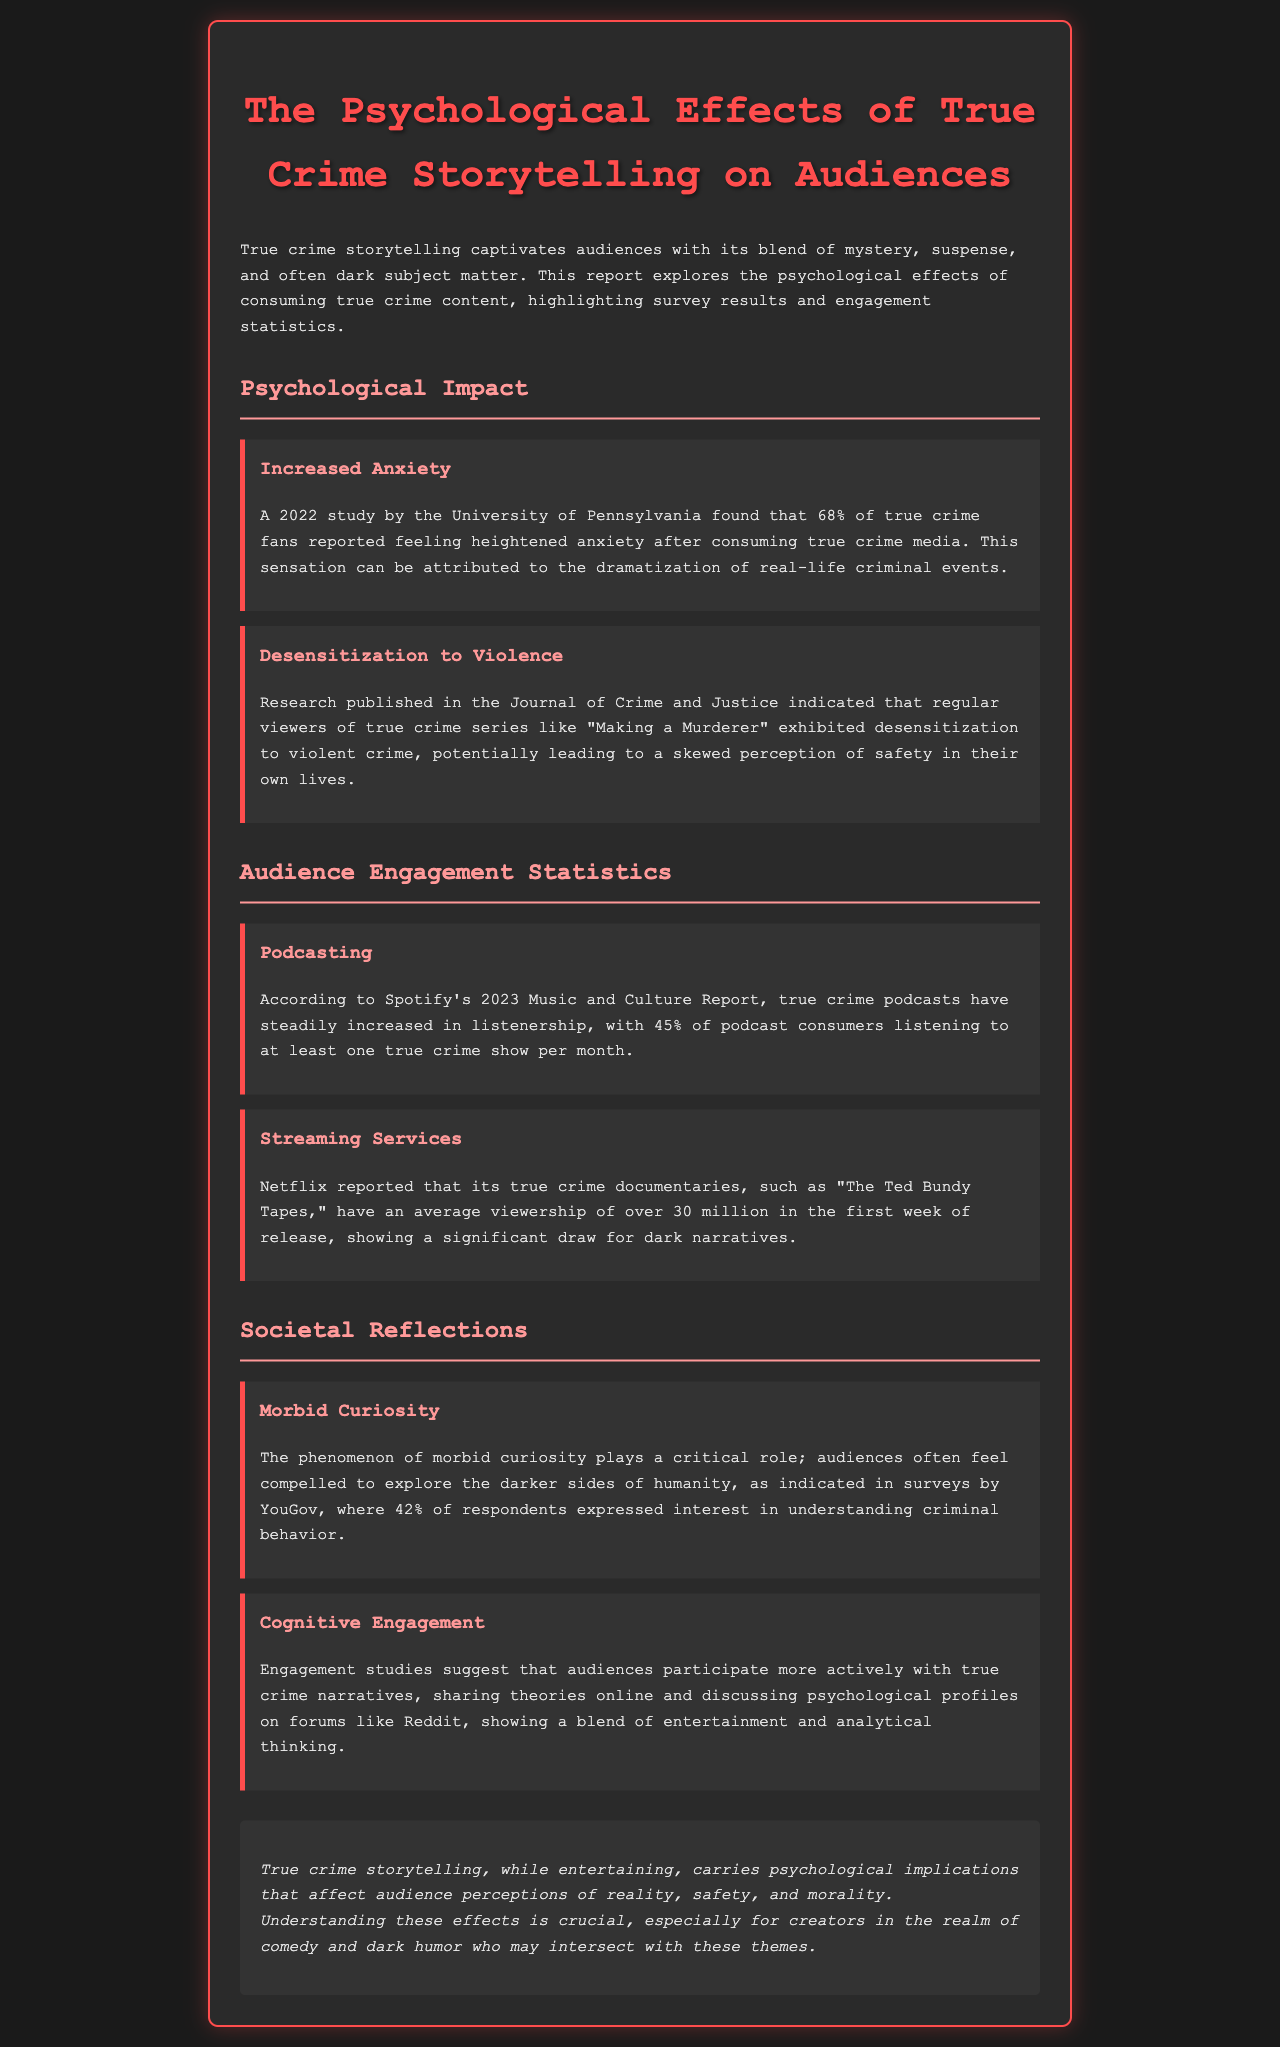What percentage of true crime fans reported heightened anxiety? The document states that 68% of true crime fans reported feeling heightened anxiety after consuming true crime media.
Answer: 68% What significant effect did regular viewers of true crime series exhibit? The report mentions desensitization to violent crime as an effect observed in regular viewers of true crime series.
Answer: Desensitization to violence How many podcast consumers listen to at least one true crime show monthly? According to Spotify's report, 45% of podcast consumers listen to at least one true crime show per month.
Answer: 45% What was the average viewership of Netflix true crime documentaries in the first week of release? The document reports that Netflix's true crime documentaries have an average viewership of over 30 million in the first week of release.
Answer: Over 30 million What is the phenomenon that compels audiences to explore the darker sides of humanity? The phenomenon is referred to as morbid curiosity, which is discussed in the document.
Answer: Morbid curiosity What percentage of respondents expressed interest in understanding criminal behavior according to YouGov? The report indicates that 42% of respondents expressed interest in understanding criminal behavior.
Answer: 42% What type of engagement do audiences show with true crime narratives? Engagement studies suggest that audiences participate more actively, sharing theories and discussing psychological profiles online.
Answer: Active participation What is a crucial understanding for creators in comedy and dark humor regarding true crime storytelling? The conclusion states that understanding psychological implications is crucial for creators in comedy and dark humor who may intersect with true crime themes.
Answer: Psychological implications 